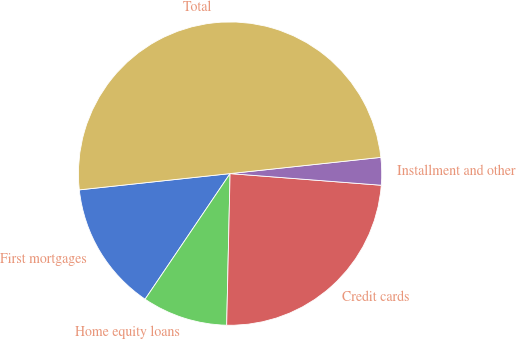Convert chart to OTSL. <chart><loc_0><loc_0><loc_500><loc_500><pie_chart><fcel>First mortgages<fcel>Home equity loans<fcel>Credit cards<fcel>Installment and other<fcel>Total<nl><fcel>13.82%<fcel>9.11%<fcel>24.13%<fcel>2.93%<fcel>50.0%<nl></chart> 